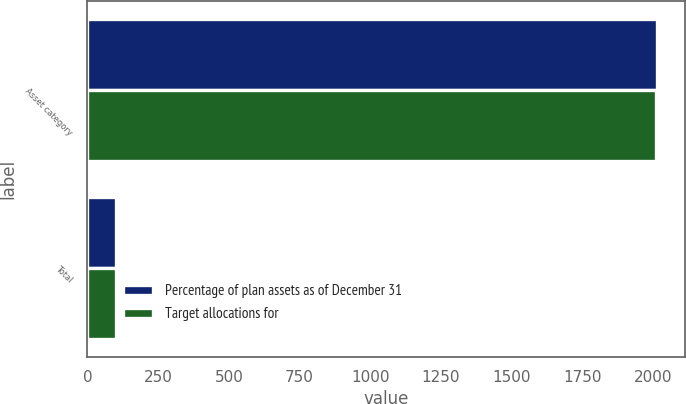Convert chart to OTSL. <chart><loc_0><loc_0><loc_500><loc_500><stacked_bar_chart><ecel><fcel>Asset category<fcel>Total<nl><fcel>Percentage of plan assets as of December 31<fcel>2013<fcel>100<nl><fcel>Target allocations for<fcel>2012<fcel>100<nl></chart> 